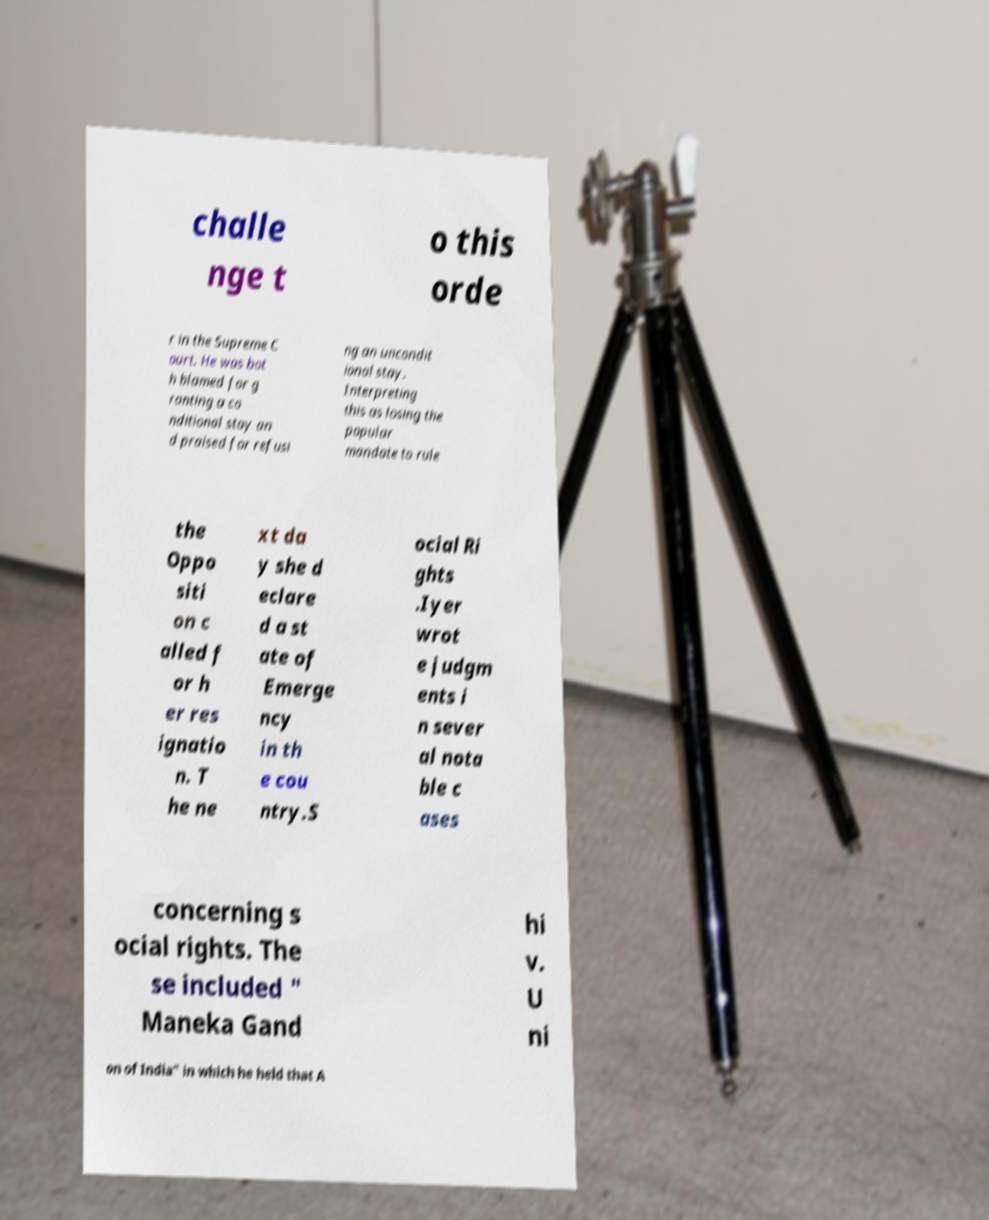I need the written content from this picture converted into text. Can you do that? challe nge t o this orde r in the Supreme C ourt. He was bot h blamed for g ranting a co nditional stay an d praised for refusi ng an uncondit ional stay. Interpreting this as losing the popular mandate to rule the Oppo siti on c alled f or h er res ignatio n. T he ne xt da y she d eclare d a st ate of Emerge ncy in th e cou ntry.S ocial Ri ghts .Iyer wrot e judgm ents i n sever al nota ble c ases concerning s ocial rights. The se included " Maneka Gand hi v. U ni on of India" in which he held that A 